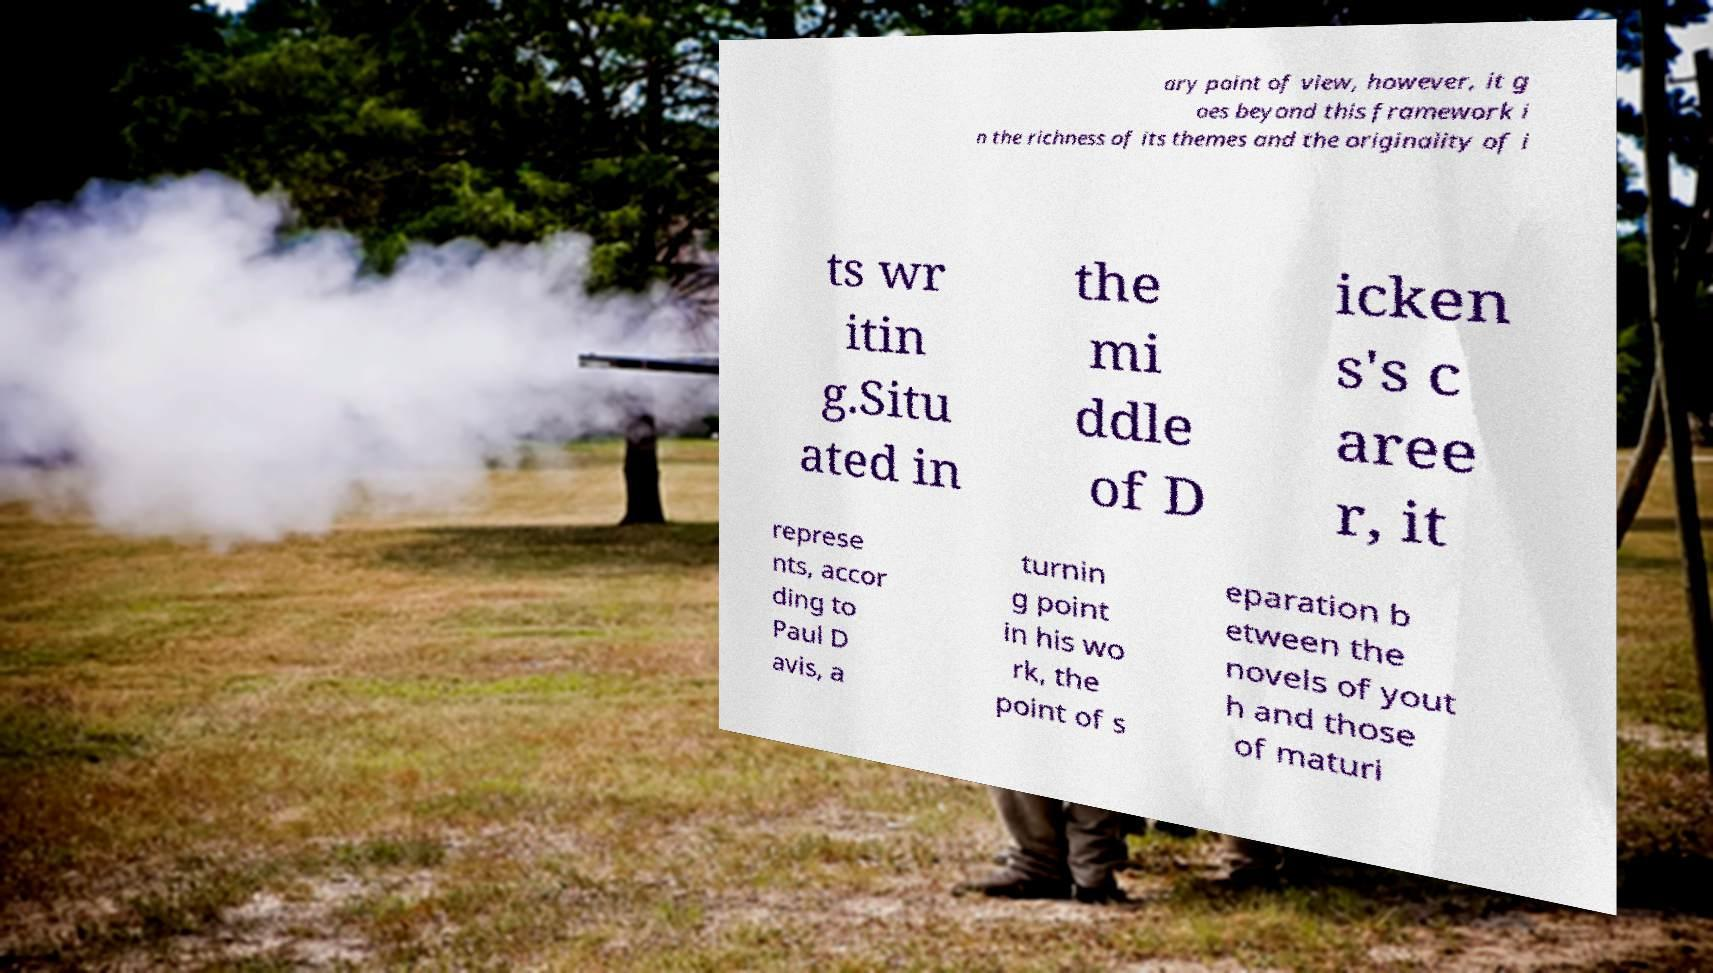Please identify and transcribe the text found in this image. ary point of view, however, it g oes beyond this framework i n the richness of its themes and the originality of i ts wr itin g.Situ ated in the mi ddle of D icken s's c aree r, it represe nts, accor ding to Paul D avis, a turnin g point in his wo rk, the point of s eparation b etween the novels of yout h and those of maturi 